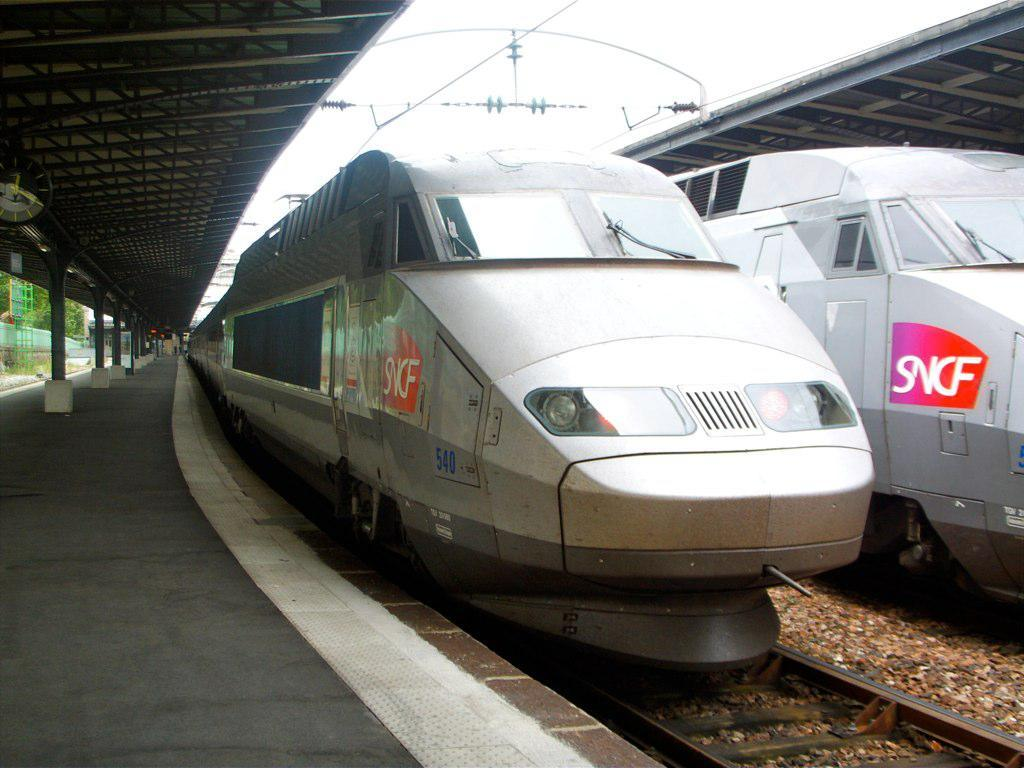Provide a one-sentence caption for the provided image. An SNCF train at the station waiting for passengers. 